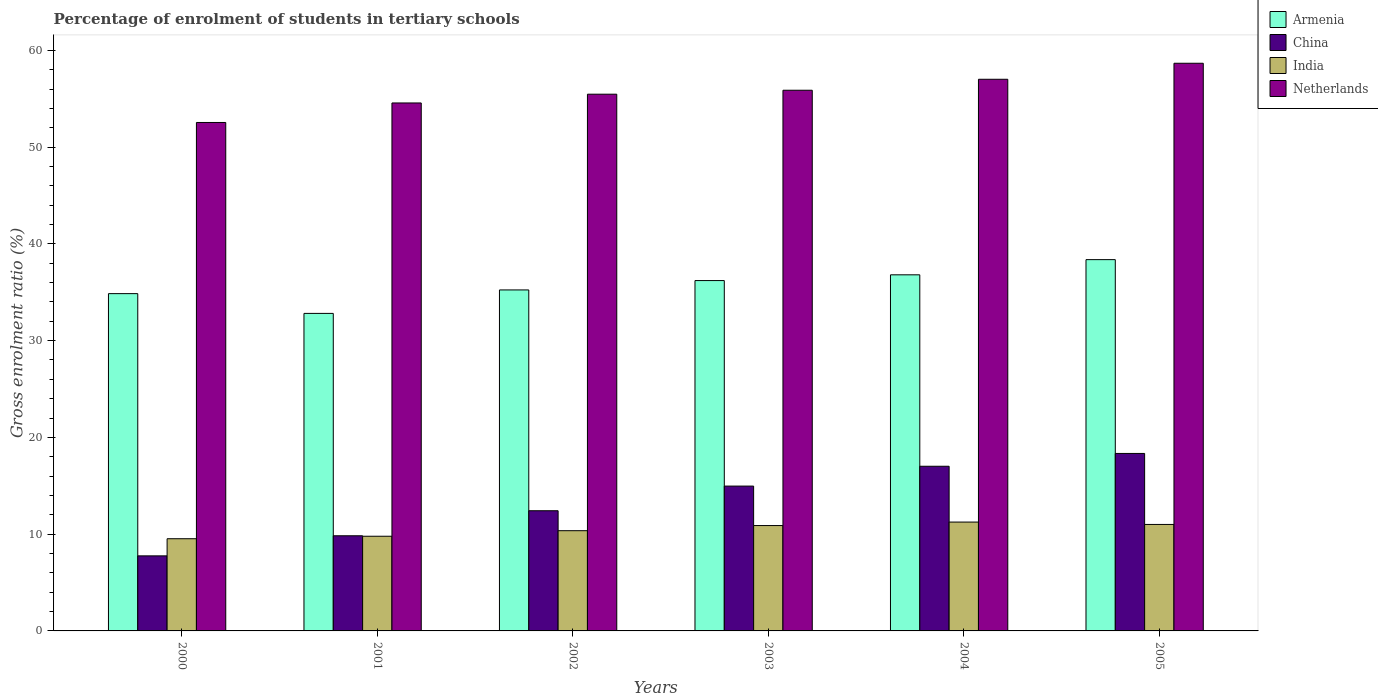Are the number of bars on each tick of the X-axis equal?
Ensure brevity in your answer.  Yes. What is the label of the 5th group of bars from the left?
Offer a terse response. 2004. In how many cases, is the number of bars for a given year not equal to the number of legend labels?
Keep it short and to the point. 0. What is the percentage of students enrolled in tertiary schools in India in 2000?
Ensure brevity in your answer.  9.53. Across all years, what is the maximum percentage of students enrolled in tertiary schools in India?
Your answer should be very brief. 11.25. Across all years, what is the minimum percentage of students enrolled in tertiary schools in Armenia?
Provide a short and direct response. 32.81. What is the total percentage of students enrolled in tertiary schools in India in the graph?
Your response must be concise. 62.81. What is the difference between the percentage of students enrolled in tertiary schools in Armenia in 2000 and that in 2005?
Give a very brief answer. -3.51. What is the difference between the percentage of students enrolled in tertiary schools in Netherlands in 2001 and the percentage of students enrolled in tertiary schools in Armenia in 2004?
Your answer should be compact. 17.76. What is the average percentage of students enrolled in tertiary schools in Netherlands per year?
Offer a terse response. 55.69. In the year 2002, what is the difference between the percentage of students enrolled in tertiary schools in India and percentage of students enrolled in tertiary schools in China?
Make the answer very short. -2.06. What is the ratio of the percentage of students enrolled in tertiary schools in Armenia in 2001 to that in 2004?
Give a very brief answer. 0.89. Is the percentage of students enrolled in tertiary schools in Armenia in 2001 less than that in 2002?
Offer a terse response. Yes. What is the difference between the highest and the second highest percentage of students enrolled in tertiary schools in Armenia?
Offer a terse response. 1.57. What is the difference between the highest and the lowest percentage of students enrolled in tertiary schools in Netherlands?
Provide a short and direct response. 6.12. Is the sum of the percentage of students enrolled in tertiary schools in India in 2000 and 2005 greater than the maximum percentage of students enrolled in tertiary schools in Armenia across all years?
Keep it short and to the point. No. What does the 3rd bar from the left in 2004 represents?
Ensure brevity in your answer.  India. What does the 4th bar from the right in 2002 represents?
Offer a terse response. Armenia. Is it the case that in every year, the sum of the percentage of students enrolled in tertiary schools in Netherlands and percentage of students enrolled in tertiary schools in Armenia is greater than the percentage of students enrolled in tertiary schools in China?
Provide a succinct answer. Yes. How many bars are there?
Offer a terse response. 24. Are all the bars in the graph horizontal?
Your answer should be very brief. No. Are the values on the major ticks of Y-axis written in scientific E-notation?
Your answer should be compact. No. How are the legend labels stacked?
Offer a very short reply. Vertical. What is the title of the graph?
Give a very brief answer. Percentage of enrolment of students in tertiary schools. Does "Uganda" appear as one of the legend labels in the graph?
Your response must be concise. No. What is the label or title of the X-axis?
Offer a terse response. Years. What is the label or title of the Y-axis?
Your response must be concise. Gross enrolment ratio (%). What is the Gross enrolment ratio (%) of Armenia in 2000?
Your response must be concise. 34.86. What is the Gross enrolment ratio (%) of China in 2000?
Provide a succinct answer. 7.76. What is the Gross enrolment ratio (%) of India in 2000?
Offer a very short reply. 9.53. What is the Gross enrolment ratio (%) of Netherlands in 2000?
Provide a short and direct response. 52.54. What is the Gross enrolment ratio (%) of Armenia in 2001?
Your answer should be very brief. 32.81. What is the Gross enrolment ratio (%) in China in 2001?
Your answer should be compact. 9.83. What is the Gross enrolment ratio (%) of India in 2001?
Your answer should be compact. 9.78. What is the Gross enrolment ratio (%) in Netherlands in 2001?
Your response must be concise. 54.56. What is the Gross enrolment ratio (%) in Armenia in 2002?
Your answer should be very brief. 35.24. What is the Gross enrolment ratio (%) in China in 2002?
Offer a terse response. 12.42. What is the Gross enrolment ratio (%) in India in 2002?
Make the answer very short. 10.36. What is the Gross enrolment ratio (%) in Netherlands in 2002?
Make the answer very short. 55.47. What is the Gross enrolment ratio (%) in Armenia in 2003?
Provide a short and direct response. 36.21. What is the Gross enrolment ratio (%) in China in 2003?
Make the answer very short. 14.97. What is the Gross enrolment ratio (%) of India in 2003?
Provide a succinct answer. 10.89. What is the Gross enrolment ratio (%) of Netherlands in 2003?
Keep it short and to the point. 55.87. What is the Gross enrolment ratio (%) in Armenia in 2004?
Your response must be concise. 36.8. What is the Gross enrolment ratio (%) in China in 2004?
Provide a succinct answer. 17.02. What is the Gross enrolment ratio (%) of India in 2004?
Ensure brevity in your answer.  11.25. What is the Gross enrolment ratio (%) of Netherlands in 2004?
Your response must be concise. 57.01. What is the Gross enrolment ratio (%) in Armenia in 2005?
Offer a terse response. 38.37. What is the Gross enrolment ratio (%) in China in 2005?
Your answer should be compact. 18.34. What is the Gross enrolment ratio (%) in India in 2005?
Make the answer very short. 11. What is the Gross enrolment ratio (%) in Netherlands in 2005?
Your answer should be compact. 58.66. Across all years, what is the maximum Gross enrolment ratio (%) in Armenia?
Ensure brevity in your answer.  38.37. Across all years, what is the maximum Gross enrolment ratio (%) of China?
Your answer should be very brief. 18.34. Across all years, what is the maximum Gross enrolment ratio (%) in India?
Make the answer very short. 11.25. Across all years, what is the maximum Gross enrolment ratio (%) in Netherlands?
Your response must be concise. 58.66. Across all years, what is the minimum Gross enrolment ratio (%) in Armenia?
Make the answer very short. 32.81. Across all years, what is the minimum Gross enrolment ratio (%) of China?
Offer a terse response. 7.76. Across all years, what is the minimum Gross enrolment ratio (%) of India?
Ensure brevity in your answer.  9.53. Across all years, what is the minimum Gross enrolment ratio (%) in Netherlands?
Provide a short and direct response. 52.54. What is the total Gross enrolment ratio (%) in Armenia in the graph?
Provide a short and direct response. 214.29. What is the total Gross enrolment ratio (%) in China in the graph?
Keep it short and to the point. 80.33. What is the total Gross enrolment ratio (%) in India in the graph?
Give a very brief answer. 62.81. What is the total Gross enrolment ratio (%) in Netherlands in the graph?
Your answer should be very brief. 334.12. What is the difference between the Gross enrolment ratio (%) in Armenia in 2000 and that in 2001?
Ensure brevity in your answer.  2.04. What is the difference between the Gross enrolment ratio (%) in China in 2000 and that in 2001?
Keep it short and to the point. -2.08. What is the difference between the Gross enrolment ratio (%) of India in 2000 and that in 2001?
Your answer should be compact. -0.26. What is the difference between the Gross enrolment ratio (%) of Netherlands in 2000 and that in 2001?
Offer a very short reply. -2.02. What is the difference between the Gross enrolment ratio (%) of Armenia in 2000 and that in 2002?
Ensure brevity in your answer.  -0.38. What is the difference between the Gross enrolment ratio (%) in China in 2000 and that in 2002?
Give a very brief answer. -4.66. What is the difference between the Gross enrolment ratio (%) in India in 2000 and that in 2002?
Offer a terse response. -0.83. What is the difference between the Gross enrolment ratio (%) in Netherlands in 2000 and that in 2002?
Offer a terse response. -2.92. What is the difference between the Gross enrolment ratio (%) in Armenia in 2000 and that in 2003?
Your answer should be compact. -1.35. What is the difference between the Gross enrolment ratio (%) in China in 2000 and that in 2003?
Your answer should be compact. -7.21. What is the difference between the Gross enrolment ratio (%) of India in 2000 and that in 2003?
Ensure brevity in your answer.  -1.36. What is the difference between the Gross enrolment ratio (%) in Netherlands in 2000 and that in 2003?
Make the answer very short. -3.33. What is the difference between the Gross enrolment ratio (%) in Armenia in 2000 and that in 2004?
Offer a terse response. -1.94. What is the difference between the Gross enrolment ratio (%) in China in 2000 and that in 2004?
Your answer should be compact. -9.26. What is the difference between the Gross enrolment ratio (%) of India in 2000 and that in 2004?
Your answer should be very brief. -1.72. What is the difference between the Gross enrolment ratio (%) of Netherlands in 2000 and that in 2004?
Ensure brevity in your answer.  -4.46. What is the difference between the Gross enrolment ratio (%) in Armenia in 2000 and that in 2005?
Ensure brevity in your answer.  -3.51. What is the difference between the Gross enrolment ratio (%) in China in 2000 and that in 2005?
Give a very brief answer. -10.58. What is the difference between the Gross enrolment ratio (%) of India in 2000 and that in 2005?
Provide a succinct answer. -1.48. What is the difference between the Gross enrolment ratio (%) of Netherlands in 2000 and that in 2005?
Ensure brevity in your answer.  -6.12. What is the difference between the Gross enrolment ratio (%) in Armenia in 2001 and that in 2002?
Provide a succinct answer. -2.43. What is the difference between the Gross enrolment ratio (%) in China in 2001 and that in 2002?
Offer a very short reply. -2.59. What is the difference between the Gross enrolment ratio (%) in India in 2001 and that in 2002?
Give a very brief answer. -0.57. What is the difference between the Gross enrolment ratio (%) of Netherlands in 2001 and that in 2002?
Ensure brevity in your answer.  -0.91. What is the difference between the Gross enrolment ratio (%) of Armenia in 2001 and that in 2003?
Your answer should be very brief. -3.39. What is the difference between the Gross enrolment ratio (%) of China in 2001 and that in 2003?
Ensure brevity in your answer.  -5.13. What is the difference between the Gross enrolment ratio (%) of India in 2001 and that in 2003?
Offer a very short reply. -1.1. What is the difference between the Gross enrolment ratio (%) in Netherlands in 2001 and that in 2003?
Provide a succinct answer. -1.31. What is the difference between the Gross enrolment ratio (%) of Armenia in 2001 and that in 2004?
Provide a succinct answer. -3.99. What is the difference between the Gross enrolment ratio (%) of China in 2001 and that in 2004?
Your answer should be compact. -7.18. What is the difference between the Gross enrolment ratio (%) of India in 2001 and that in 2004?
Your response must be concise. -1.46. What is the difference between the Gross enrolment ratio (%) in Netherlands in 2001 and that in 2004?
Provide a short and direct response. -2.45. What is the difference between the Gross enrolment ratio (%) of Armenia in 2001 and that in 2005?
Provide a succinct answer. -5.55. What is the difference between the Gross enrolment ratio (%) in China in 2001 and that in 2005?
Keep it short and to the point. -8.51. What is the difference between the Gross enrolment ratio (%) in India in 2001 and that in 2005?
Your response must be concise. -1.22. What is the difference between the Gross enrolment ratio (%) in Netherlands in 2001 and that in 2005?
Your answer should be very brief. -4.1. What is the difference between the Gross enrolment ratio (%) in Armenia in 2002 and that in 2003?
Your answer should be compact. -0.97. What is the difference between the Gross enrolment ratio (%) in China in 2002 and that in 2003?
Your response must be concise. -2.55. What is the difference between the Gross enrolment ratio (%) in India in 2002 and that in 2003?
Your response must be concise. -0.53. What is the difference between the Gross enrolment ratio (%) in Netherlands in 2002 and that in 2003?
Offer a very short reply. -0.41. What is the difference between the Gross enrolment ratio (%) of Armenia in 2002 and that in 2004?
Give a very brief answer. -1.56. What is the difference between the Gross enrolment ratio (%) of China in 2002 and that in 2004?
Keep it short and to the point. -4.6. What is the difference between the Gross enrolment ratio (%) of India in 2002 and that in 2004?
Ensure brevity in your answer.  -0.89. What is the difference between the Gross enrolment ratio (%) of Netherlands in 2002 and that in 2004?
Provide a succinct answer. -1.54. What is the difference between the Gross enrolment ratio (%) of Armenia in 2002 and that in 2005?
Ensure brevity in your answer.  -3.13. What is the difference between the Gross enrolment ratio (%) in China in 2002 and that in 2005?
Offer a terse response. -5.92. What is the difference between the Gross enrolment ratio (%) in India in 2002 and that in 2005?
Keep it short and to the point. -0.65. What is the difference between the Gross enrolment ratio (%) of Netherlands in 2002 and that in 2005?
Give a very brief answer. -3.2. What is the difference between the Gross enrolment ratio (%) in Armenia in 2003 and that in 2004?
Offer a terse response. -0.59. What is the difference between the Gross enrolment ratio (%) in China in 2003 and that in 2004?
Provide a succinct answer. -2.05. What is the difference between the Gross enrolment ratio (%) in India in 2003 and that in 2004?
Ensure brevity in your answer.  -0.36. What is the difference between the Gross enrolment ratio (%) in Netherlands in 2003 and that in 2004?
Give a very brief answer. -1.13. What is the difference between the Gross enrolment ratio (%) in Armenia in 2003 and that in 2005?
Your answer should be very brief. -2.16. What is the difference between the Gross enrolment ratio (%) in China in 2003 and that in 2005?
Your response must be concise. -3.37. What is the difference between the Gross enrolment ratio (%) of India in 2003 and that in 2005?
Offer a terse response. -0.12. What is the difference between the Gross enrolment ratio (%) in Netherlands in 2003 and that in 2005?
Your response must be concise. -2.79. What is the difference between the Gross enrolment ratio (%) in Armenia in 2004 and that in 2005?
Ensure brevity in your answer.  -1.57. What is the difference between the Gross enrolment ratio (%) of China in 2004 and that in 2005?
Provide a succinct answer. -1.32. What is the difference between the Gross enrolment ratio (%) of India in 2004 and that in 2005?
Provide a succinct answer. 0.25. What is the difference between the Gross enrolment ratio (%) in Netherlands in 2004 and that in 2005?
Offer a terse response. -1.66. What is the difference between the Gross enrolment ratio (%) in Armenia in 2000 and the Gross enrolment ratio (%) in China in 2001?
Provide a succinct answer. 25.02. What is the difference between the Gross enrolment ratio (%) in Armenia in 2000 and the Gross enrolment ratio (%) in India in 2001?
Ensure brevity in your answer.  25.07. What is the difference between the Gross enrolment ratio (%) in Armenia in 2000 and the Gross enrolment ratio (%) in Netherlands in 2001?
Provide a short and direct response. -19.7. What is the difference between the Gross enrolment ratio (%) in China in 2000 and the Gross enrolment ratio (%) in India in 2001?
Provide a short and direct response. -2.03. What is the difference between the Gross enrolment ratio (%) of China in 2000 and the Gross enrolment ratio (%) of Netherlands in 2001?
Offer a very short reply. -46.8. What is the difference between the Gross enrolment ratio (%) of India in 2000 and the Gross enrolment ratio (%) of Netherlands in 2001?
Offer a very short reply. -45.03. What is the difference between the Gross enrolment ratio (%) in Armenia in 2000 and the Gross enrolment ratio (%) in China in 2002?
Provide a short and direct response. 22.44. What is the difference between the Gross enrolment ratio (%) of Armenia in 2000 and the Gross enrolment ratio (%) of India in 2002?
Your answer should be very brief. 24.5. What is the difference between the Gross enrolment ratio (%) in Armenia in 2000 and the Gross enrolment ratio (%) in Netherlands in 2002?
Ensure brevity in your answer.  -20.61. What is the difference between the Gross enrolment ratio (%) of China in 2000 and the Gross enrolment ratio (%) of Netherlands in 2002?
Give a very brief answer. -47.71. What is the difference between the Gross enrolment ratio (%) of India in 2000 and the Gross enrolment ratio (%) of Netherlands in 2002?
Your response must be concise. -45.94. What is the difference between the Gross enrolment ratio (%) in Armenia in 2000 and the Gross enrolment ratio (%) in China in 2003?
Provide a succinct answer. 19.89. What is the difference between the Gross enrolment ratio (%) in Armenia in 2000 and the Gross enrolment ratio (%) in India in 2003?
Your answer should be very brief. 23.97. What is the difference between the Gross enrolment ratio (%) in Armenia in 2000 and the Gross enrolment ratio (%) in Netherlands in 2003?
Make the answer very short. -21.02. What is the difference between the Gross enrolment ratio (%) in China in 2000 and the Gross enrolment ratio (%) in India in 2003?
Offer a very short reply. -3.13. What is the difference between the Gross enrolment ratio (%) in China in 2000 and the Gross enrolment ratio (%) in Netherlands in 2003?
Offer a very short reply. -48.12. What is the difference between the Gross enrolment ratio (%) of India in 2000 and the Gross enrolment ratio (%) of Netherlands in 2003?
Provide a short and direct response. -46.35. What is the difference between the Gross enrolment ratio (%) of Armenia in 2000 and the Gross enrolment ratio (%) of China in 2004?
Your answer should be very brief. 17.84. What is the difference between the Gross enrolment ratio (%) in Armenia in 2000 and the Gross enrolment ratio (%) in India in 2004?
Make the answer very short. 23.61. What is the difference between the Gross enrolment ratio (%) of Armenia in 2000 and the Gross enrolment ratio (%) of Netherlands in 2004?
Ensure brevity in your answer.  -22.15. What is the difference between the Gross enrolment ratio (%) in China in 2000 and the Gross enrolment ratio (%) in India in 2004?
Offer a very short reply. -3.49. What is the difference between the Gross enrolment ratio (%) in China in 2000 and the Gross enrolment ratio (%) in Netherlands in 2004?
Your response must be concise. -49.25. What is the difference between the Gross enrolment ratio (%) of India in 2000 and the Gross enrolment ratio (%) of Netherlands in 2004?
Give a very brief answer. -47.48. What is the difference between the Gross enrolment ratio (%) of Armenia in 2000 and the Gross enrolment ratio (%) of China in 2005?
Keep it short and to the point. 16.52. What is the difference between the Gross enrolment ratio (%) in Armenia in 2000 and the Gross enrolment ratio (%) in India in 2005?
Your response must be concise. 23.85. What is the difference between the Gross enrolment ratio (%) in Armenia in 2000 and the Gross enrolment ratio (%) in Netherlands in 2005?
Your response must be concise. -23.81. What is the difference between the Gross enrolment ratio (%) of China in 2000 and the Gross enrolment ratio (%) of India in 2005?
Offer a terse response. -3.25. What is the difference between the Gross enrolment ratio (%) of China in 2000 and the Gross enrolment ratio (%) of Netherlands in 2005?
Offer a very short reply. -50.91. What is the difference between the Gross enrolment ratio (%) in India in 2000 and the Gross enrolment ratio (%) in Netherlands in 2005?
Your response must be concise. -49.14. What is the difference between the Gross enrolment ratio (%) of Armenia in 2001 and the Gross enrolment ratio (%) of China in 2002?
Your answer should be very brief. 20.39. What is the difference between the Gross enrolment ratio (%) in Armenia in 2001 and the Gross enrolment ratio (%) in India in 2002?
Provide a succinct answer. 22.46. What is the difference between the Gross enrolment ratio (%) in Armenia in 2001 and the Gross enrolment ratio (%) in Netherlands in 2002?
Ensure brevity in your answer.  -22.65. What is the difference between the Gross enrolment ratio (%) of China in 2001 and the Gross enrolment ratio (%) of India in 2002?
Your answer should be compact. -0.52. What is the difference between the Gross enrolment ratio (%) in China in 2001 and the Gross enrolment ratio (%) in Netherlands in 2002?
Your response must be concise. -45.63. What is the difference between the Gross enrolment ratio (%) of India in 2001 and the Gross enrolment ratio (%) of Netherlands in 2002?
Provide a succinct answer. -45.68. What is the difference between the Gross enrolment ratio (%) of Armenia in 2001 and the Gross enrolment ratio (%) of China in 2003?
Your response must be concise. 17.85. What is the difference between the Gross enrolment ratio (%) of Armenia in 2001 and the Gross enrolment ratio (%) of India in 2003?
Your answer should be compact. 21.93. What is the difference between the Gross enrolment ratio (%) in Armenia in 2001 and the Gross enrolment ratio (%) in Netherlands in 2003?
Provide a succinct answer. -23.06. What is the difference between the Gross enrolment ratio (%) in China in 2001 and the Gross enrolment ratio (%) in India in 2003?
Offer a terse response. -1.06. What is the difference between the Gross enrolment ratio (%) of China in 2001 and the Gross enrolment ratio (%) of Netherlands in 2003?
Provide a short and direct response. -46.04. What is the difference between the Gross enrolment ratio (%) of India in 2001 and the Gross enrolment ratio (%) of Netherlands in 2003?
Your answer should be compact. -46.09. What is the difference between the Gross enrolment ratio (%) in Armenia in 2001 and the Gross enrolment ratio (%) in China in 2004?
Offer a very short reply. 15.8. What is the difference between the Gross enrolment ratio (%) of Armenia in 2001 and the Gross enrolment ratio (%) of India in 2004?
Offer a very short reply. 21.57. What is the difference between the Gross enrolment ratio (%) in Armenia in 2001 and the Gross enrolment ratio (%) in Netherlands in 2004?
Your response must be concise. -24.19. What is the difference between the Gross enrolment ratio (%) in China in 2001 and the Gross enrolment ratio (%) in India in 2004?
Keep it short and to the point. -1.42. What is the difference between the Gross enrolment ratio (%) in China in 2001 and the Gross enrolment ratio (%) in Netherlands in 2004?
Provide a succinct answer. -47.17. What is the difference between the Gross enrolment ratio (%) in India in 2001 and the Gross enrolment ratio (%) in Netherlands in 2004?
Provide a succinct answer. -47.22. What is the difference between the Gross enrolment ratio (%) in Armenia in 2001 and the Gross enrolment ratio (%) in China in 2005?
Your response must be concise. 14.47. What is the difference between the Gross enrolment ratio (%) of Armenia in 2001 and the Gross enrolment ratio (%) of India in 2005?
Your answer should be compact. 21.81. What is the difference between the Gross enrolment ratio (%) in Armenia in 2001 and the Gross enrolment ratio (%) in Netherlands in 2005?
Your response must be concise. -25.85. What is the difference between the Gross enrolment ratio (%) in China in 2001 and the Gross enrolment ratio (%) in India in 2005?
Provide a succinct answer. -1.17. What is the difference between the Gross enrolment ratio (%) in China in 2001 and the Gross enrolment ratio (%) in Netherlands in 2005?
Your response must be concise. -48.83. What is the difference between the Gross enrolment ratio (%) in India in 2001 and the Gross enrolment ratio (%) in Netherlands in 2005?
Your answer should be very brief. -48.88. What is the difference between the Gross enrolment ratio (%) in Armenia in 2002 and the Gross enrolment ratio (%) in China in 2003?
Make the answer very short. 20.27. What is the difference between the Gross enrolment ratio (%) of Armenia in 2002 and the Gross enrolment ratio (%) of India in 2003?
Make the answer very short. 24.35. What is the difference between the Gross enrolment ratio (%) of Armenia in 2002 and the Gross enrolment ratio (%) of Netherlands in 2003?
Your answer should be compact. -20.64. What is the difference between the Gross enrolment ratio (%) in China in 2002 and the Gross enrolment ratio (%) in India in 2003?
Provide a short and direct response. 1.53. What is the difference between the Gross enrolment ratio (%) of China in 2002 and the Gross enrolment ratio (%) of Netherlands in 2003?
Offer a terse response. -43.45. What is the difference between the Gross enrolment ratio (%) in India in 2002 and the Gross enrolment ratio (%) in Netherlands in 2003?
Offer a terse response. -45.52. What is the difference between the Gross enrolment ratio (%) in Armenia in 2002 and the Gross enrolment ratio (%) in China in 2004?
Make the answer very short. 18.22. What is the difference between the Gross enrolment ratio (%) of Armenia in 2002 and the Gross enrolment ratio (%) of India in 2004?
Provide a short and direct response. 23.99. What is the difference between the Gross enrolment ratio (%) in Armenia in 2002 and the Gross enrolment ratio (%) in Netherlands in 2004?
Give a very brief answer. -21.77. What is the difference between the Gross enrolment ratio (%) of China in 2002 and the Gross enrolment ratio (%) of India in 2004?
Give a very brief answer. 1.17. What is the difference between the Gross enrolment ratio (%) of China in 2002 and the Gross enrolment ratio (%) of Netherlands in 2004?
Give a very brief answer. -44.59. What is the difference between the Gross enrolment ratio (%) of India in 2002 and the Gross enrolment ratio (%) of Netherlands in 2004?
Your answer should be compact. -46.65. What is the difference between the Gross enrolment ratio (%) of Armenia in 2002 and the Gross enrolment ratio (%) of China in 2005?
Offer a terse response. 16.9. What is the difference between the Gross enrolment ratio (%) in Armenia in 2002 and the Gross enrolment ratio (%) in India in 2005?
Give a very brief answer. 24.24. What is the difference between the Gross enrolment ratio (%) of Armenia in 2002 and the Gross enrolment ratio (%) of Netherlands in 2005?
Provide a succinct answer. -23.42. What is the difference between the Gross enrolment ratio (%) of China in 2002 and the Gross enrolment ratio (%) of India in 2005?
Your answer should be compact. 1.42. What is the difference between the Gross enrolment ratio (%) in China in 2002 and the Gross enrolment ratio (%) in Netherlands in 2005?
Your answer should be very brief. -46.24. What is the difference between the Gross enrolment ratio (%) of India in 2002 and the Gross enrolment ratio (%) of Netherlands in 2005?
Offer a very short reply. -48.31. What is the difference between the Gross enrolment ratio (%) in Armenia in 2003 and the Gross enrolment ratio (%) in China in 2004?
Give a very brief answer. 19.19. What is the difference between the Gross enrolment ratio (%) of Armenia in 2003 and the Gross enrolment ratio (%) of India in 2004?
Keep it short and to the point. 24.96. What is the difference between the Gross enrolment ratio (%) in Armenia in 2003 and the Gross enrolment ratio (%) in Netherlands in 2004?
Provide a short and direct response. -20.8. What is the difference between the Gross enrolment ratio (%) of China in 2003 and the Gross enrolment ratio (%) of India in 2004?
Keep it short and to the point. 3.72. What is the difference between the Gross enrolment ratio (%) of China in 2003 and the Gross enrolment ratio (%) of Netherlands in 2004?
Offer a very short reply. -42.04. What is the difference between the Gross enrolment ratio (%) of India in 2003 and the Gross enrolment ratio (%) of Netherlands in 2004?
Your response must be concise. -46.12. What is the difference between the Gross enrolment ratio (%) in Armenia in 2003 and the Gross enrolment ratio (%) in China in 2005?
Ensure brevity in your answer.  17.87. What is the difference between the Gross enrolment ratio (%) in Armenia in 2003 and the Gross enrolment ratio (%) in India in 2005?
Your answer should be very brief. 25.2. What is the difference between the Gross enrolment ratio (%) of Armenia in 2003 and the Gross enrolment ratio (%) of Netherlands in 2005?
Offer a very short reply. -22.46. What is the difference between the Gross enrolment ratio (%) in China in 2003 and the Gross enrolment ratio (%) in India in 2005?
Your answer should be very brief. 3.96. What is the difference between the Gross enrolment ratio (%) of China in 2003 and the Gross enrolment ratio (%) of Netherlands in 2005?
Make the answer very short. -43.7. What is the difference between the Gross enrolment ratio (%) of India in 2003 and the Gross enrolment ratio (%) of Netherlands in 2005?
Offer a very short reply. -47.77. What is the difference between the Gross enrolment ratio (%) of Armenia in 2004 and the Gross enrolment ratio (%) of China in 2005?
Your answer should be very brief. 18.46. What is the difference between the Gross enrolment ratio (%) of Armenia in 2004 and the Gross enrolment ratio (%) of India in 2005?
Your response must be concise. 25.8. What is the difference between the Gross enrolment ratio (%) of Armenia in 2004 and the Gross enrolment ratio (%) of Netherlands in 2005?
Your response must be concise. -21.86. What is the difference between the Gross enrolment ratio (%) in China in 2004 and the Gross enrolment ratio (%) in India in 2005?
Provide a succinct answer. 6.01. What is the difference between the Gross enrolment ratio (%) of China in 2004 and the Gross enrolment ratio (%) of Netherlands in 2005?
Provide a succinct answer. -41.65. What is the difference between the Gross enrolment ratio (%) in India in 2004 and the Gross enrolment ratio (%) in Netherlands in 2005?
Your answer should be very brief. -47.41. What is the average Gross enrolment ratio (%) in Armenia per year?
Your response must be concise. 35.71. What is the average Gross enrolment ratio (%) in China per year?
Offer a terse response. 13.39. What is the average Gross enrolment ratio (%) in India per year?
Ensure brevity in your answer.  10.47. What is the average Gross enrolment ratio (%) in Netherlands per year?
Keep it short and to the point. 55.69. In the year 2000, what is the difference between the Gross enrolment ratio (%) in Armenia and Gross enrolment ratio (%) in China?
Provide a short and direct response. 27.1. In the year 2000, what is the difference between the Gross enrolment ratio (%) of Armenia and Gross enrolment ratio (%) of India?
Give a very brief answer. 25.33. In the year 2000, what is the difference between the Gross enrolment ratio (%) of Armenia and Gross enrolment ratio (%) of Netherlands?
Provide a short and direct response. -17.69. In the year 2000, what is the difference between the Gross enrolment ratio (%) of China and Gross enrolment ratio (%) of India?
Your answer should be very brief. -1.77. In the year 2000, what is the difference between the Gross enrolment ratio (%) of China and Gross enrolment ratio (%) of Netherlands?
Give a very brief answer. -44.79. In the year 2000, what is the difference between the Gross enrolment ratio (%) of India and Gross enrolment ratio (%) of Netherlands?
Keep it short and to the point. -43.02. In the year 2001, what is the difference between the Gross enrolment ratio (%) of Armenia and Gross enrolment ratio (%) of China?
Offer a very short reply. 22.98. In the year 2001, what is the difference between the Gross enrolment ratio (%) of Armenia and Gross enrolment ratio (%) of India?
Your answer should be very brief. 23.03. In the year 2001, what is the difference between the Gross enrolment ratio (%) in Armenia and Gross enrolment ratio (%) in Netherlands?
Provide a short and direct response. -21.75. In the year 2001, what is the difference between the Gross enrolment ratio (%) in China and Gross enrolment ratio (%) in India?
Your answer should be very brief. 0.05. In the year 2001, what is the difference between the Gross enrolment ratio (%) of China and Gross enrolment ratio (%) of Netherlands?
Provide a short and direct response. -44.73. In the year 2001, what is the difference between the Gross enrolment ratio (%) in India and Gross enrolment ratio (%) in Netherlands?
Your response must be concise. -44.78. In the year 2002, what is the difference between the Gross enrolment ratio (%) of Armenia and Gross enrolment ratio (%) of China?
Offer a terse response. 22.82. In the year 2002, what is the difference between the Gross enrolment ratio (%) in Armenia and Gross enrolment ratio (%) in India?
Offer a very short reply. 24.88. In the year 2002, what is the difference between the Gross enrolment ratio (%) in Armenia and Gross enrolment ratio (%) in Netherlands?
Your response must be concise. -20.23. In the year 2002, what is the difference between the Gross enrolment ratio (%) of China and Gross enrolment ratio (%) of India?
Make the answer very short. 2.06. In the year 2002, what is the difference between the Gross enrolment ratio (%) in China and Gross enrolment ratio (%) in Netherlands?
Offer a terse response. -43.05. In the year 2002, what is the difference between the Gross enrolment ratio (%) in India and Gross enrolment ratio (%) in Netherlands?
Offer a very short reply. -45.11. In the year 2003, what is the difference between the Gross enrolment ratio (%) of Armenia and Gross enrolment ratio (%) of China?
Your answer should be very brief. 21.24. In the year 2003, what is the difference between the Gross enrolment ratio (%) of Armenia and Gross enrolment ratio (%) of India?
Make the answer very short. 25.32. In the year 2003, what is the difference between the Gross enrolment ratio (%) of Armenia and Gross enrolment ratio (%) of Netherlands?
Ensure brevity in your answer.  -19.67. In the year 2003, what is the difference between the Gross enrolment ratio (%) in China and Gross enrolment ratio (%) in India?
Your answer should be compact. 4.08. In the year 2003, what is the difference between the Gross enrolment ratio (%) of China and Gross enrolment ratio (%) of Netherlands?
Offer a terse response. -40.91. In the year 2003, what is the difference between the Gross enrolment ratio (%) in India and Gross enrolment ratio (%) in Netherlands?
Your answer should be very brief. -44.99. In the year 2004, what is the difference between the Gross enrolment ratio (%) in Armenia and Gross enrolment ratio (%) in China?
Your answer should be very brief. 19.78. In the year 2004, what is the difference between the Gross enrolment ratio (%) in Armenia and Gross enrolment ratio (%) in India?
Ensure brevity in your answer.  25.55. In the year 2004, what is the difference between the Gross enrolment ratio (%) in Armenia and Gross enrolment ratio (%) in Netherlands?
Provide a short and direct response. -20.21. In the year 2004, what is the difference between the Gross enrolment ratio (%) in China and Gross enrolment ratio (%) in India?
Provide a succinct answer. 5.77. In the year 2004, what is the difference between the Gross enrolment ratio (%) of China and Gross enrolment ratio (%) of Netherlands?
Offer a terse response. -39.99. In the year 2004, what is the difference between the Gross enrolment ratio (%) in India and Gross enrolment ratio (%) in Netherlands?
Your response must be concise. -45.76. In the year 2005, what is the difference between the Gross enrolment ratio (%) of Armenia and Gross enrolment ratio (%) of China?
Your response must be concise. 20.03. In the year 2005, what is the difference between the Gross enrolment ratio (%) of Armenia and Gross enrolment ratio (%) of India?
Provide a short and direct response. 27.36. In the year 2005, what is the difference between the Gross enrolment ratio (%) in Armenia and Gross enrolment ratio (%) in Netherlands?
Your response must be concise. -20.29. In the year 2005, what is the difference between the Gross enrolment ratio (%) of China and Gross enrolment ratio (%) of India?
Your answer should be compact. 7.34. In the year 2005, what is the difference between the Gross enrolment ratio (%) in China and Gross enrolment ratio (%) in Netherlands?
Offer a terse response. -40.32. In the year 2005, what is the difference between the Gross enrolment ratio (%) in India and Gross enrolment ratio (%) in Netherlands?
Your answer should be compact. -47.66. What is the ratio of the Gross enrolment ratio (%) of Armenia in 2000 to that in 2001?
Ensure brevity in your answer.  1.06. What is the ratio of the Gross enrolment ratio (%) in China in 2000 to that in 2001?
Ensure brevity in your answer.  0.79. What is the ratio of the Gross enrolment ratio (%) in India in 2000 to that in 2001?
Ensure brevity in your answer.  0.97. What is the ratio of the Gross enrolment ratio (%) of Netherlands in 2000 to that in 2001?
Make the answer very short. 0.96. What is the ratio of the Gross enrolment ratio (%) of Armenia in 2000 to that in 2002?
Your answer should be compact. 0.99. What is the ratio of the Gross enrolment ratio (%) in China in 2000 to that in 2002?
Your answer should be compact. 0.62. What is the ratio of the Gross enrolment ratio (%) of India in 2000 to that in 2002?
Your answer should be compact. 0.92. What is the ratio of the Gross enrolment ratio (%) of Netherlands in 2000 to that in 2002?
Provide a short and direct response. 0.95. What is the ratio of the Gross enrolment ratio (%) in Armenia in 2000 to that in 2003?
Provide a short and direct response. 0.96. What is the ratio of the Gross enrolment ratio (%) in China in 2000 to that in 2003?
Ensure brevity in your answer.  0.52. What is the ratio of the Gross enrolment ratio (%) in India in 2000 to that in 2003?
Offer a very short reply. 0.87. What is the ratio of the Gross enrolment ratio (%) in Netherlands in 2000 to that in 2003?
Your answer should be very brief. 0.94. What is the ratio of the Gross enrolment ratio (%) of Armenia in 2000 to that in 2004?
Provide a short and direct response. 0.95. What is the ratio of the Gross enrolment ratio (%) in China in 2000 to that in 2004?
Provide a short and direct response. 0.46. What is the ratio of the Gross enrolment ratio (%) in India in 2000 to that in 2004?
Give a very brief answer. 0.85. What is the ratio of the Gross enrolment ratio (%) in Netherlands in 2000 to that in 2004?
Keep it short and to the point. 0.92. What is the ratio of the Gross enrolment ratio (%) of Armenia in 2000 to that in 2005?
Make the answer very short. 0.91. What is the ratio of the Gross enrolment ratio (%) of China in 2000 to that in 2005?
Your answer should be very brief. 0.42. What is the ratio of the Gross enrolment ratio (%) in India in 2000 to that in 2005?
Offer a terse response. 0.87. What is the ratio of the Gross enrolment ratio (%) in Netherlands in 2000 to that in 2005?
Your response must be concise. 0.9. What is the ratio of the Gross enrolment ratio (%) of Armenia in 2001 to that in 2002?
Ensure brevity in your answer.  0.93. What is the ratio of the Gross enrolment ratio (%) in China in 2001 to that in 2002?
Give a very brief answer. 0.79. What is the ratio of the Gross enrolment ratio (%) of India in 2001 to that in 2002?
Provide a short and direct response. 0.94. What is the ratio of the Gross enrolment ratio (%) in Netherlands in 2001 to that in 2002?
Offer a very short reply. 0.98. What is the ratio of the Gross enrolment ratio (%) of Armenia in 2001 to that in 2003?
Offer a terse response. 0.91. What is the ratio of the Gross enrolment ratio (%) in China in 2001 to that in 2003?
Offer a terse response. 0.66. What is the ratio of the Gross enrolment ratio (%) of India in 2001 to that in 2003?
Make the answer very short. 0.9. What is the ratio of the Gross enrolment ratio (%) in Netherlands in 2001 to that in 2003?
Ensure brevity in your answer.  0.98. What is the ratio of the Gross enrolment ratio (%) in Armenia in 2001 to that in 2004?
Provide a succinct answer. 0.89. What is the ratio of the Gross enrolment ratio (%) in China in 2001 to that in 2004?
Your answer should be compact. 0.58. What is the ratio of the Gross enrolment ratio (%) in India in 2001 to that in 2004?
Ensure brevity in your answer.  0.87. What is the ratio of the Gross enrolment ratio (%) of Netherlands in 2001 to that in 2004?
Provide a short and direct response. 0.96. What is the ratio of the Gross enrolment ratio (%) in Armenia in 2001 to that in 2005?
Your answer should be compact. 0.86. What is the ratio of the Gross enrolment ratio (%) in China in 2001 to that in 2005?
Your answer should be very brief. 0.54. What is the ratio of the Gross enrolment ratio (%) in India in 2001 to that in 2005?
Offer a very short reply. 0.89. What is the ratio of the Gross enrolment ratio (%) in Netherlands in 2001 to that in 2005?
Your response must be concise. 0.93. What is the ratio of the Gross enrolment ratio (%) of Armenia in 2002 to that in 2003?
Your answer should be compact. 0.97. What is the ratio of the Gross enrolment ratio (%) in China in 2002 to that in 2003?
Make the answer very short. 0.83. What is the ratio of the Gross enrolment ratio (%) of India in 2002 to that in 2003?
Make the answer very short. 0.95. What is the ratio of the Gross enrolment ratio (%) of Netherlands in 2002 to that in 2003?
Your answer should be very brief. 0.99. What is the ratio of the Gross enrolment ratio (%) of Armenia in 2002 to that in 2004?
Your answer should be very brief. 0.96. What is the ratio of the Gross enrolment ratio (%) of China in 2002 to that in 2004?
Provide a short and direct response. 0.73. What is the ratio of the Gross enrolment ratio (%) of India in 2002 to that in 2004?
Make the answer very short. 0.92. What is the ratio of the Gross enrolment ratio (%) of Armenia in 2002 to that in 2005?
Provide a succinct answer. 0.92. What is the ratio of the Gross enrolment ratio (%) of China in 2002 to that in 2005?
Ensure brevity in your answer.  0.68. What is the ratio of the Gross enrolment ratio (%) of India in 2002 to that in 2005?
Give a very brief answer. 0.94. What is the ratio of the Gross enrolment ratio (%) of Netherlands in 2002 to that in 2005?
Provide a succinct answer. 0.95. What is the ratio of the Gross enrolment ratio (%) in Armenia in 2003 to that in 2004?
Provide a succinct answer. 0.98. What is the ratio of the Gross enrolment ratio (%) in China in 2003 to that in 2004?
Keep it short and to the point. 0.88. What is the ratio of the Gross enrolment ratio (%) of India in 2003 to that in 2004?
Provide a succinct answer. 0.97. What is the ratio of the Gross enrolment ratio (%) in Netherlands in 2003 to that in 2004?
Offer a terse response. 0.98. What is the ratio of the Gross enrolment ratio (%) of Armenia in 2003 to that in 2005?
Provide a short and direct response. 0.94. What is the ratio of the Gross enrolment ratio (%) in China in 2003 to that in 2005?
Provide a short and direct response. 0.82. What is the ratio of the Gross enrolment ratio (%) in India in 2003 to that in 2005?
Offer a very short reply. 0.99. What is the ratio of the Gross enrolment ratio (%) in Netherlands in 2003 to that in 2005?
Provide a short and direct response. 0.95. What is the ratio of the Gross enrolment ratio (%) of Armenia in 2004 to that in 2005?
Offer a very short reply. 0.96. What is the ratio of the Gross enrolment ratio (%) in China in 2004 to that in 2005?
Your response must be concise. 0.93. What is the ratio of the Gross enrolment ratio (%) of India in 2004 to that in 2005?
Your answer should be compact. 1.02. What is the ratio of the Gross enrolment ratio (%) of Netherlands in 2004 to that in 2005?
Make the answer very short. 0.97. What is the difference between the highest and the second highest Gross enrolment ratio (%) of Armenia?
Keep it short and to the point. 1.57. What is the difference between the highest and the second highest Gross enrolment ratio (%) of China?
Provide a short and direct response. 1.32. What is the difference between the highest and the second highest Gross enrolment ratio (%) in India?
Ensure brevity in your answer.  0.25. What is the difference between the highest and the second highest Gross enrolment ratio (%) in Netherlands?
Keep it short and to the point. 1.66. What is the difference between the highest and the lowest Gross enrolment ratio (%) of Armenia?
Provide a short and direct response. 5.55. What is the difference between the highest and the lowest Gross enrolment ratio (%) in China?
Provide a short and direct response. 10.58. What is the difference between the highest and the lowest Gross enrolment ratio (%) of India?
Make the answer very short. 1.72. What is the difference between the highest and the lowest Gross enrolment ratio (%) in Netherlands?
Offer a very short reply. 6.12. 